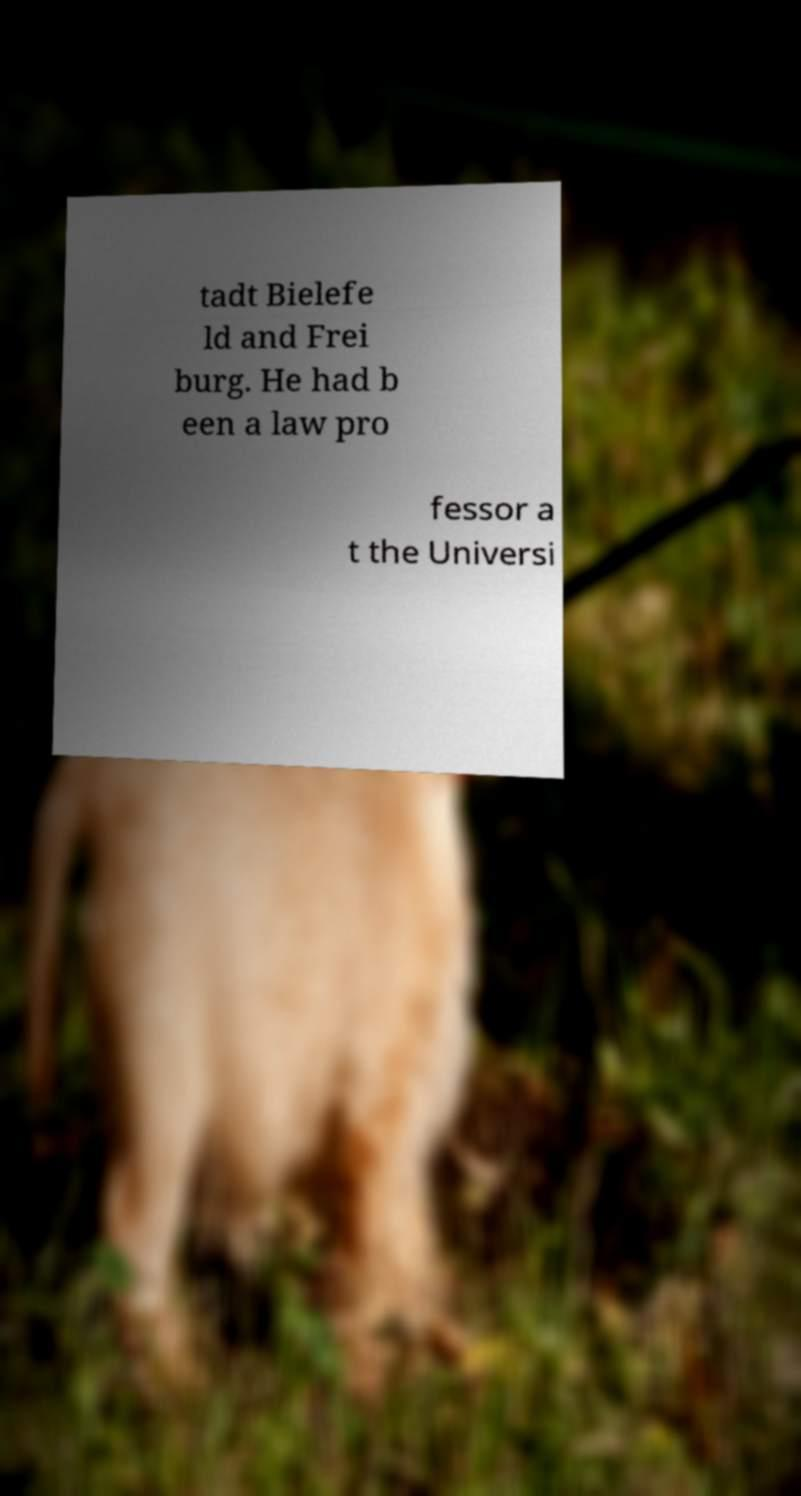Could you assist in decoding the text presented in this image and type it out clearly? tadt Bielefe ld and Frei burg. He had b een a law pro fessor a t the Universi 